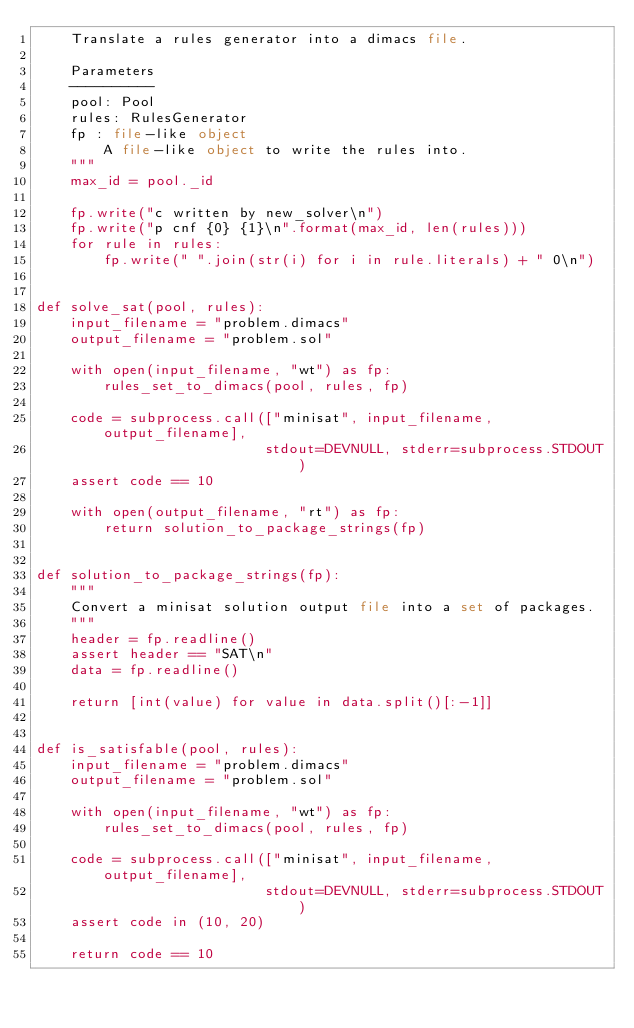Convert code to text. <code><loc_0><loc_0><loc_500><loc_500><_Python_>    Translate a rules generator into a dimacs file.

    Parameters
    ----------
    pool: Pool
    rules: RulesGenerator
    fp : file-like object
        A file-like object to write the rules into.
    """
    max_id = pool._id

    fp.write("c written by new_solver\n")
    fp.write("p cnf {0} {1}\n".format(max_id, len(rules)))
    for rule in rules:
        fp.write(" ".join(str(i) for i in rule.literals) + " 0\n")


def solve_sat(pool, rules):
    input_filename = "problem.dimacs"
    output_filename = "problem.sol"

    with open(input_filename, "wt") as fp:
        rules_set_to_dimacs(pool, rules, fp)

    code = subprocess.call(["minisat", input_filename, output_filename],
                           stdout=DEVNULL, stderr=subprocess.STDOUT)
    assert code == 10

    with open(output_filename, "rt") as fp:
        return solution_to_package_strings(fp)


def solution_to_package_strings(fp):
    """
    Convert a minisat solution output file into a set of packages.
    """
    header = fp.readline()
    assert header == "SAT\n"
    data = fp.readline()

    return [int(value) for value in data.split()[:-1]]


def is_satisfable(pool, rules):
    input_filename = "problem.dimacs"
    output_filename = "problem.sol"

    with open(input_filename, "wt") as fp:
        rules_set_to_dimacs(pool, rules, fp)

    code = subprocess.call(["minisat", input_filename, output_filename],
                           stdout=DEVNULL, stderr=subprocess.STDOUT)
    assert code in (10, 20)

    return code == 10
</code> 